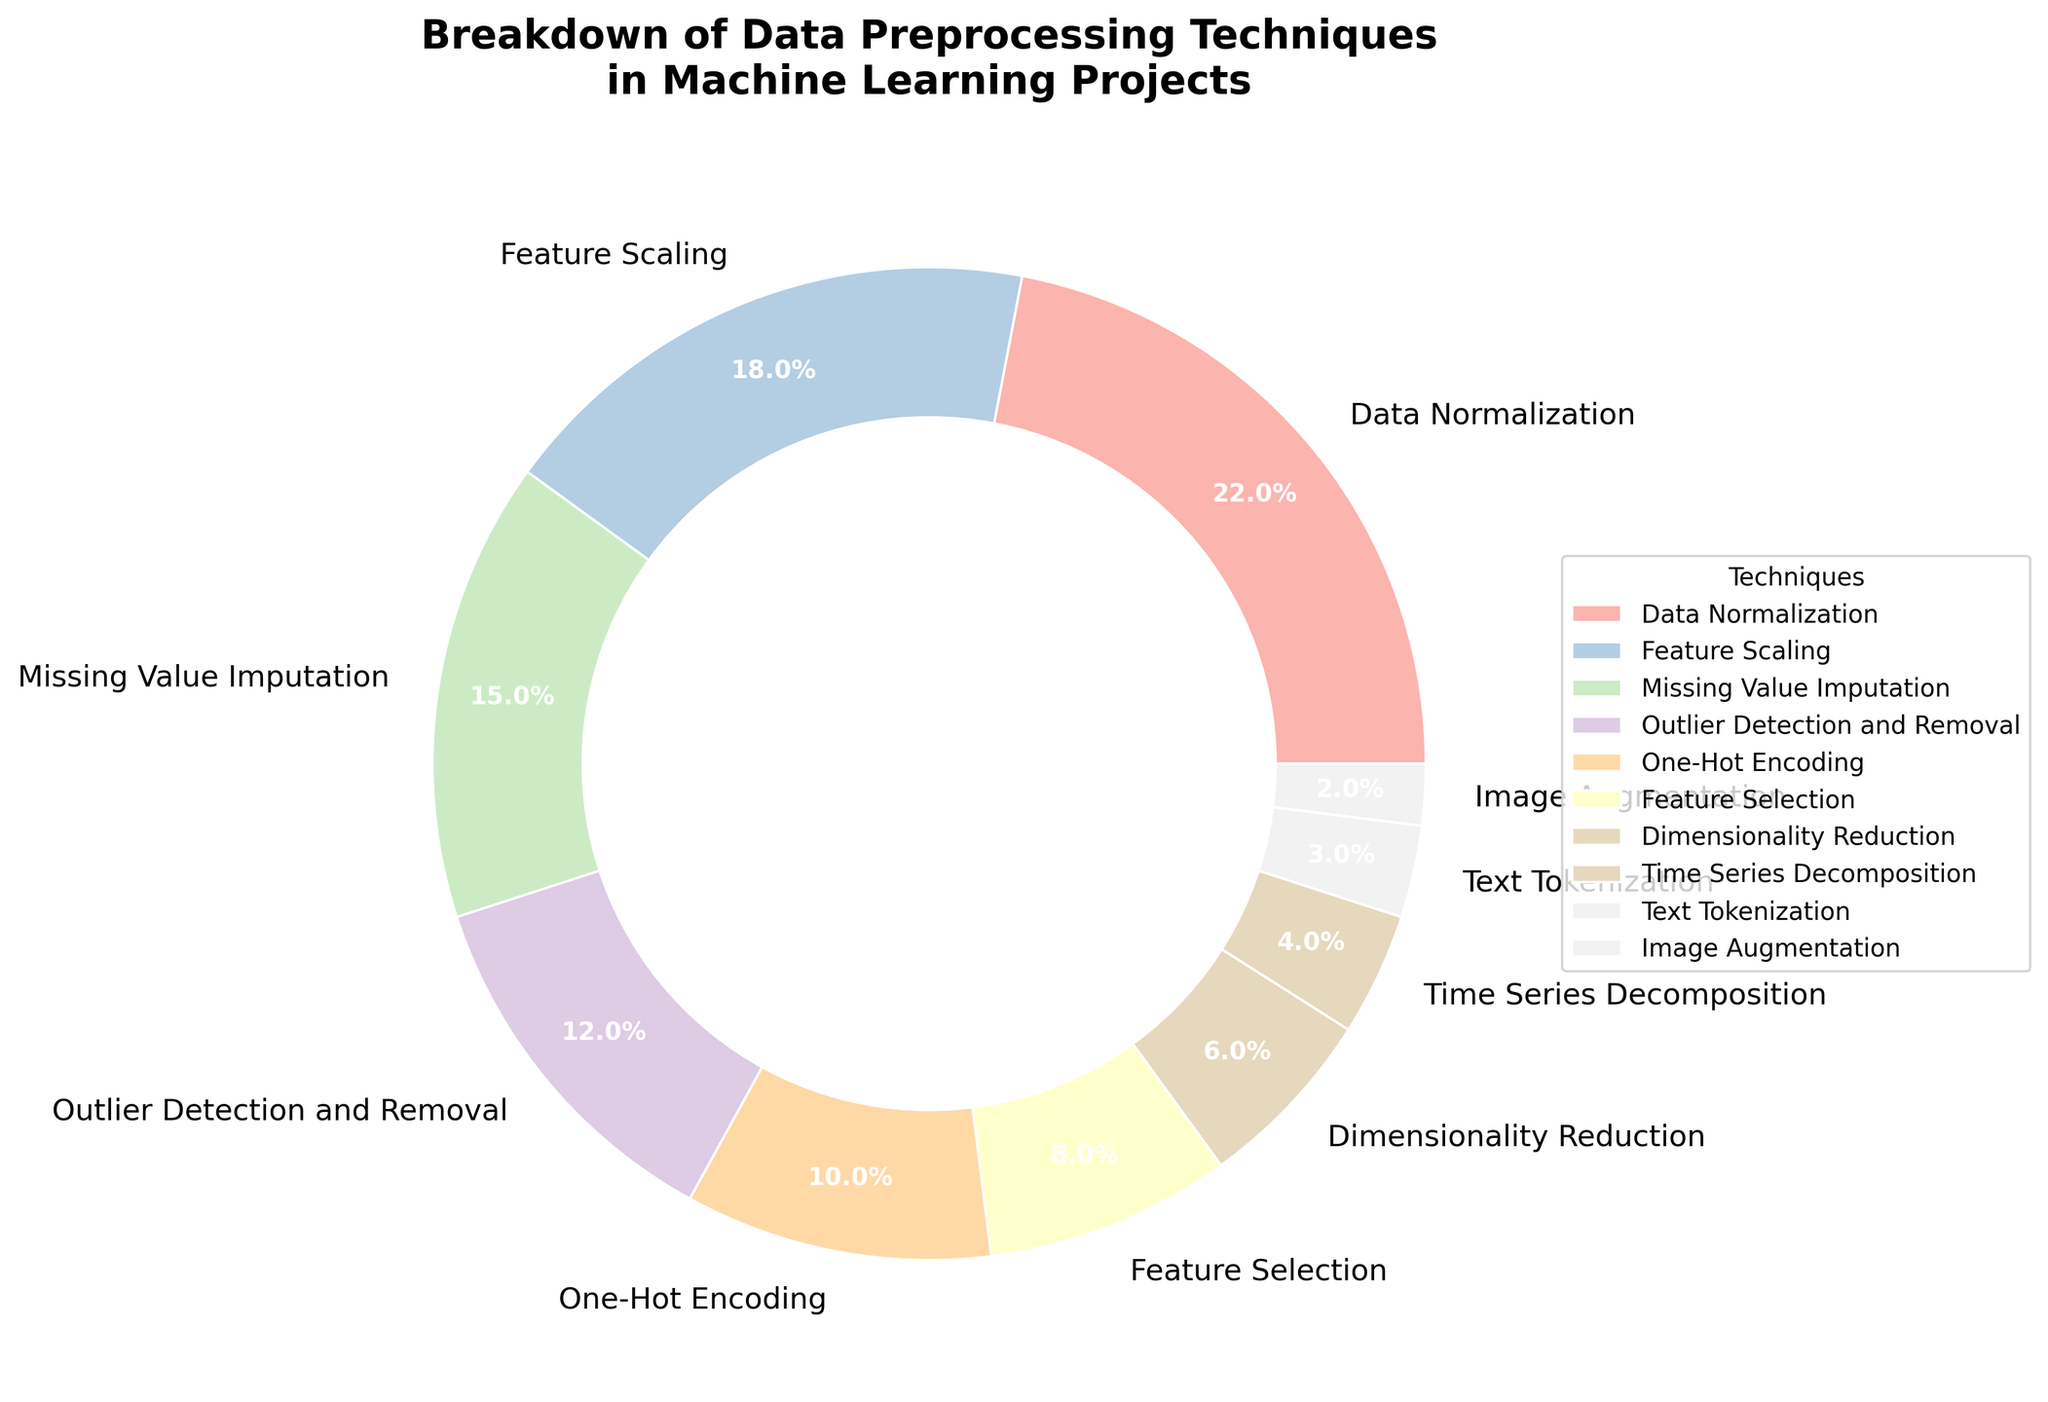What is the most common data preprocessing technique used? By looking at the pie chart, we can see the section with the highest percentage. The slice for "Data Normalization" is the largest, indicating it is the most common technique.
Answer: Data Normalization How many techniques have a usage percentage less than 10%? Observing the pie chart, the segments for techniques with less than 10% are Feature Selection, Dimensionality Reduction, Time Series Decomposition, Text Tokenization, and Image Augmentation. Counting these gives us five techniques.
Answer: 5 What is the combined percentage of techniques employed more than 15%? Techniques with usage more than 15% are Data Normalization (22%), Feature Scaling (18%). Adding these gives 22% + 18% = 40%.
Answer: 40% Which technique is employed least and what is its percentage? By looking at the smallest slice of the pie chart, Image Augmentation is the least employed technique with the smallest percentage of 2%.
Answer: Image Augmentation, 2% Is One-Hot Encoding used more than Feature Selection? By comparing the sizes of the slices labeled "One-Hot Encoding" and "Feature Selection," we see that One-Hot Encoding (10%) is indeed used more than Feature Selection (8%).
Answer: Yes What techniques together contribute precisely 30% of the total usage? Combining percentages, we find that Outlier Detection and Removal (12%) and Missing Value Imputation (15%) together make 27%, and adding Text Tokenization (3%) gives exactly 30%.
Answer: Outlier Detection and Removal, Missing Value Imputation, and Text Tokenization What is the total percentage of techniques related to feature engineering (Feature Scaling, Feature Selection, Dimensionality Reduction)? Adding the figures for Feature Scaling (18%), Feature Selection (8%), and Dimensionality Reduction (6%) provides the total: 18% + 8% + 6% = 32%.
Answer: 32% How much larger is the usage of Data Normalization compared to Dimensionality Reduction? The percentage for Data Normalization (22%) is subtracted by the percentage for Dimensionality Reduction (6%). The calculation is 22% - 6% = 16%.
Answer: 16% Which techniques have their usage represented by a visually similar sized section in the pie chart? By visually inspecting the pie chart, Feature Scaling (18%) and Missing Value Imputation (15%) have sections that appear similarly sized.
Answer: Feature Scaling and Missing Value Imputation What is the average percentage usage of techniques used for feature engineering? The relevant techniques are Feature Scaling (18%), Feature Selection (8%), and Dimensionality Reduction (6%). Summing them gives 18% + 8% + 6% = 32%. The average is 32% / 3 = approximately 10.67%.
Answer: 10.67% 